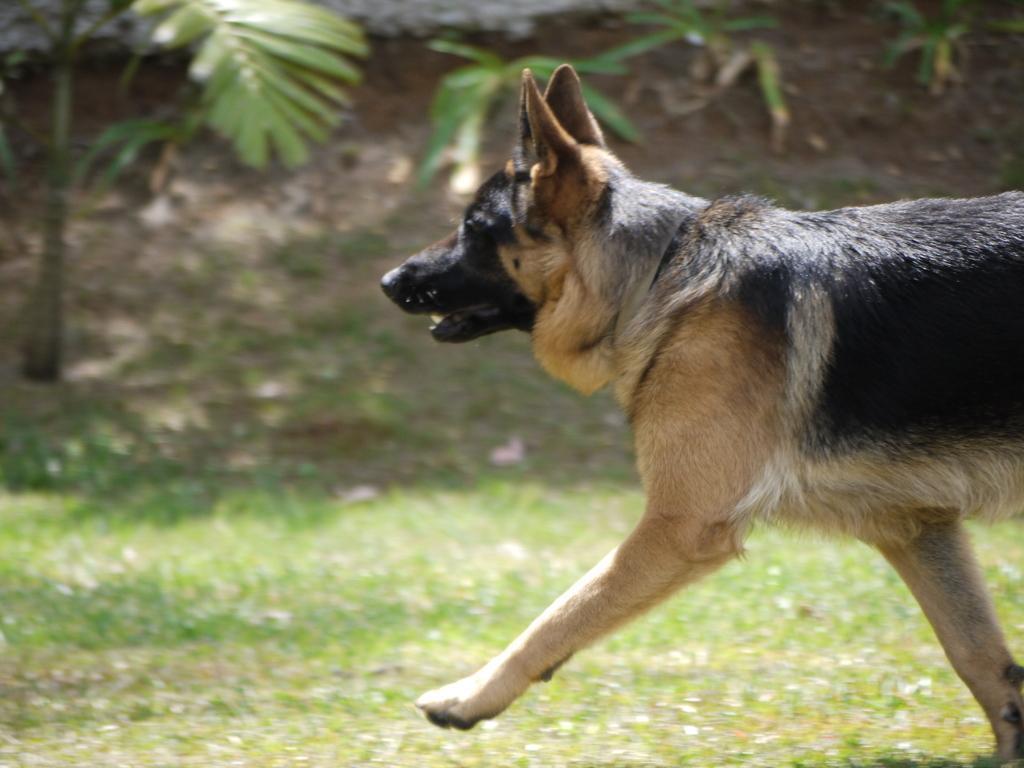Could you give a brief overview of what you see in this image? In this image there is a dog walking on the grass beside that there is mountain and trees. 